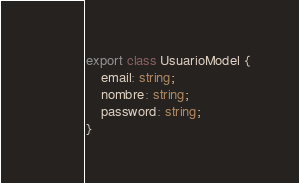Convert code to text. <code><loc_0><loc_0><loc_500><loc_500><_TypeScript_>export class UsuarioModel {
    email: string;
    nombre: string;
    password: string;
}</code> 